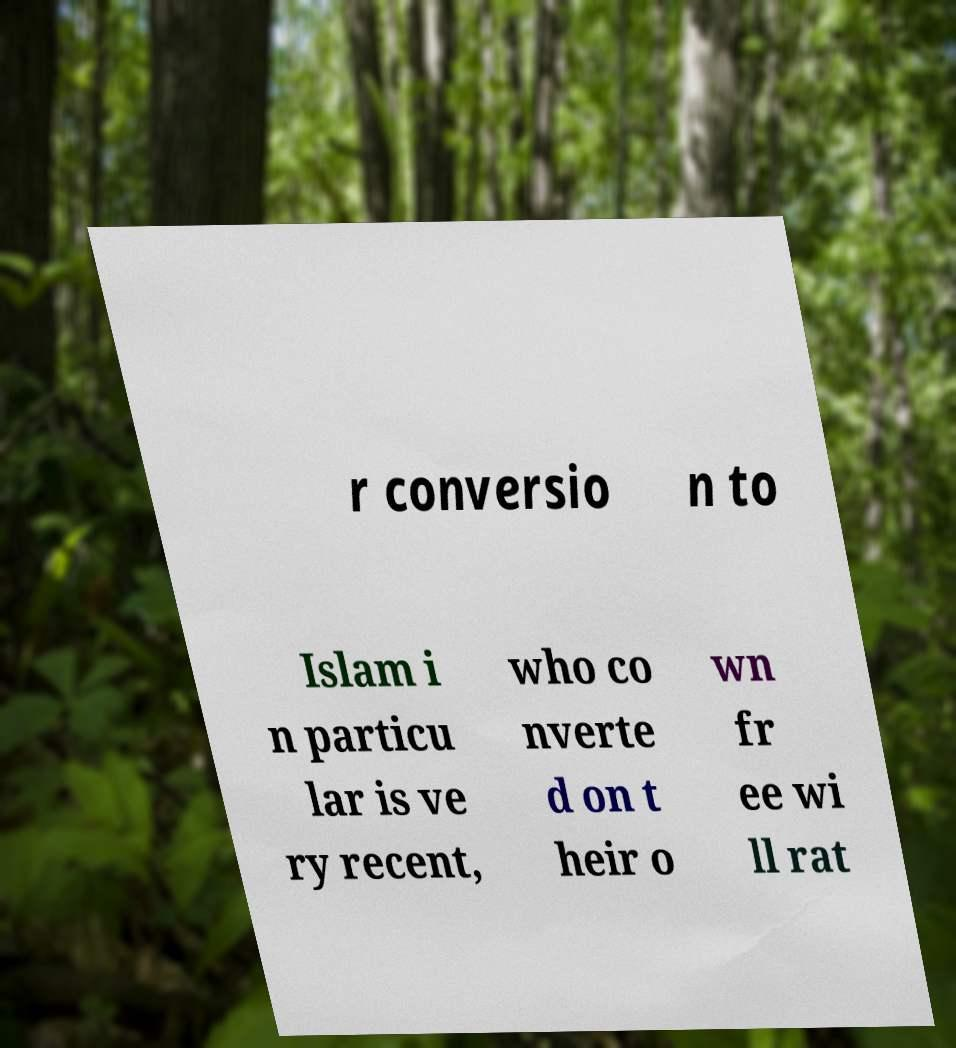Could you extract and type out the text from this image? r conversio n to Islam i n particu lar is ve ry recent, who co nverte d on t heir o wn fr ee wi ll rat 